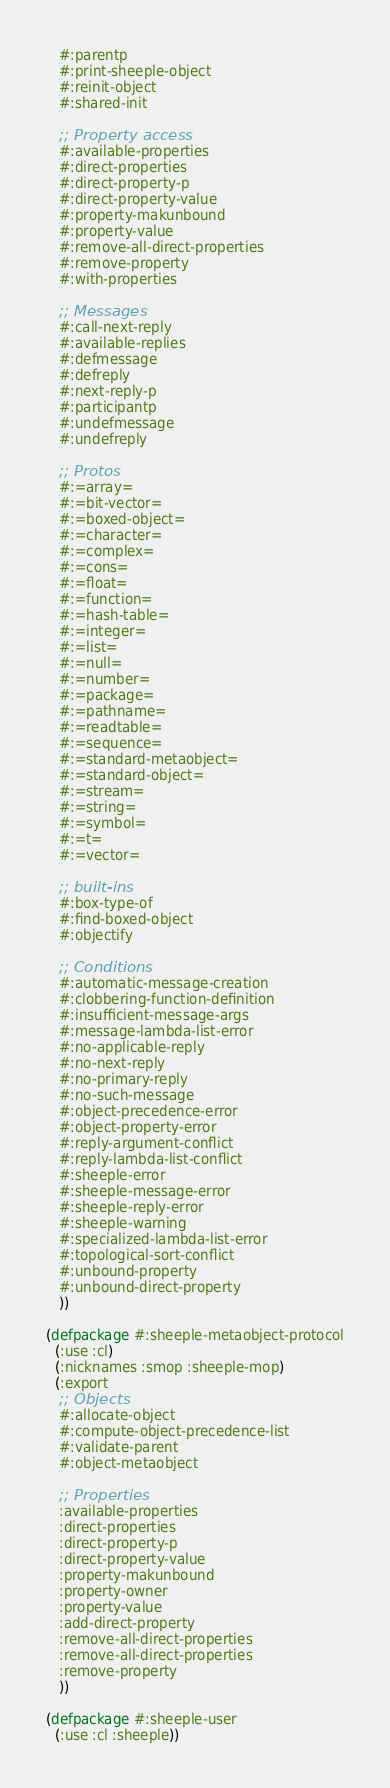<code> <loc_0><loc_0><loc_500><loc_500><_Lisp_>   #:parentp
   #:print-sheeple-object
   #:reinit-object
   #:shared-init

   ;; Property access
   #:available-properties
   #:direct-properties
   #:direct-property-p
   #:direct-property-value
   #:property-makunbound
   #:property-value
   #:remove-all-direct-properties
   #:remove-property
   #:with-properties

   ;; Messages
   #:call-next-reply
   #:available-replies
   #:defmessage
   #:defreply
   #:next-reply-p
   #:participantp
   #:undefmessage
   #:undefreply

   ;; Protos
   #:=array=
   #:=bit-vector=
   #:=boxed-object=
   #:=character=
   #:=complex=
   #:=cons=
   #:=float=
   #:=function=
   #:=hash-table=
   #:=integer=
   #:=list=
   #:=null=
   #:=number=
   #:=package=
   #:=pathname=
   #:=readtable=
   #:=sequence=
   #:=standard-metaobject=
   #:=standard-object=
   #:=stream=
   #:=string=
   #:=symbol=
   #:=t=
   #:=vector=

   ;; built-ins
   #:box-type-of
   #:find-boxed-object
   #:objectify

   ;; Conditions
   #:automatic-message-creation
   #:clobbering-function-definition
   #:insufficient-message-args
   #:message-lambda-list-error
   #:no-applicable-reply
   #:no-next-reply
   #:no-primary-reply
   #:no-such-message
   #:object-precedence-error
   #:object-property-error
   #:reply-argument-conflict
   #:reply-lambda-list-conflict
   #:sheeple-error
   #:sheeple-message-error
   #:sheeple-reply-error
   #:sheeple-warning
   #:specialized-lambda-list-error
   #:topological-sort-conflict
   #:unbound-property
   #:unbound-direct-property
   ))

(defpackage #:sheeple-metaobject-protocol
  (:use :cl)
  (:nicknames :smop :sheeple-mop)
  (:export
   ;; Objects
   #:allocate-object
   #:compute-object-precedence-list
   #:validate-parent
   #:object-metaobject

   ;; Properties
   :available-properties
   :direct-properties
   :direct-property-p
   :direct-property-value
   :property-makunbound
   :property-owner
   :property-value
   :add-direct-property
   :remove-all-direct-properties
   :remove-all-direct-properties
   :remove-property
   ))

(defpackage #:sheeple-user
  (:use :cl :sheeple))
</code> 